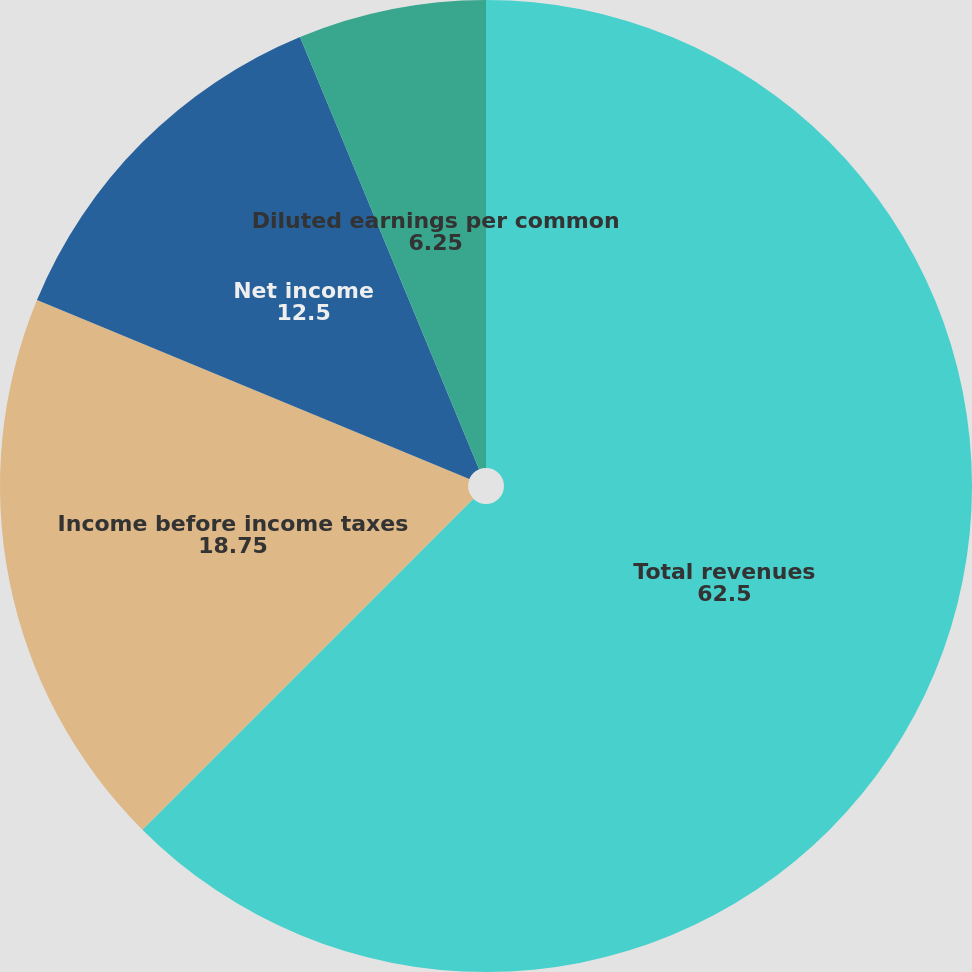Convert chart. <chart><loc_0><loc_0><loc_500><loc_500><pie_chart><fcel>Total revenues<fcel>Income before income taxes<fcel>Net income<fcel>Basic earnings per common<fcel>Diluted earnings per common<nl><fcel>62.5%<fcel>18.75%<fcel>12.5%<fcel>0.0%<fcel>6.25%<nl></chart> 